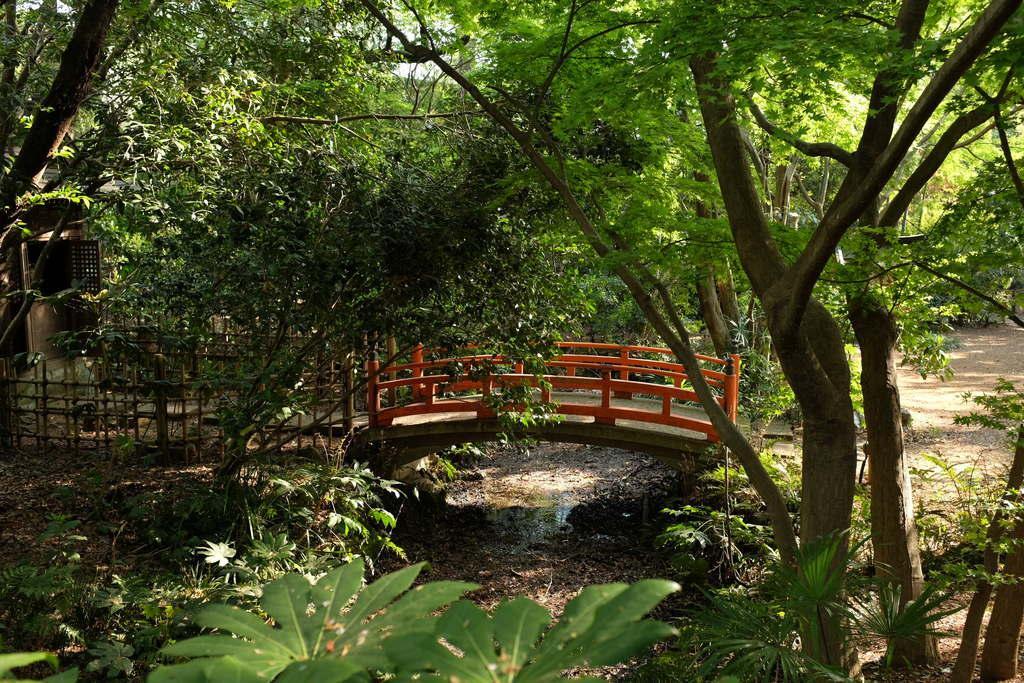Please provide a concise description of this image. In this image I see the trees and I see the bridge over here and I see the ground and I can also see the fencing over here and I see the water over here. 